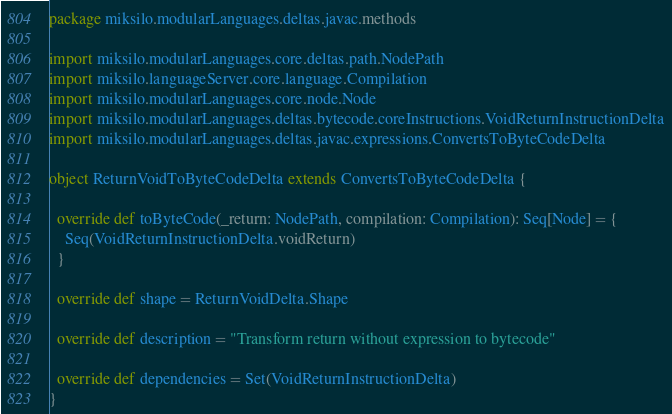<code> <loc_0><loc_0><loc_500><loc_500><_Scala_>package miksilo.modularLanguages.deltas.javac.methods

import miksilo.modularLanguages.core.deltas.path.NodePath
import miksilo.languageServer.core.language.Compilation
import miksilo.modularLanguages.core.node.Node
import miksilo.modularLanguages.deltas.bytecode.coreInstructions.VoidReturnInstructionDelta
import miksilo.modularLanguages.deltas.javac.expressions.ConvertsToByteCodeDelta

object ReturnVoidToByteCodeDelta extends ConvertsToByteCodeDelta {

  override def toByteCode(_return: NodePath, compilation: Compilation): Seq[Node] = {
    Seq(VoidReturnInstructionDelta.voidReturn)
  }

  override def shape = ReturnVoidDelta.Shape

  override def description = "Transform return without expression to bytecode"

  override def dependencies = Set(VoidReturnInstructionDelta)
}
</code> 